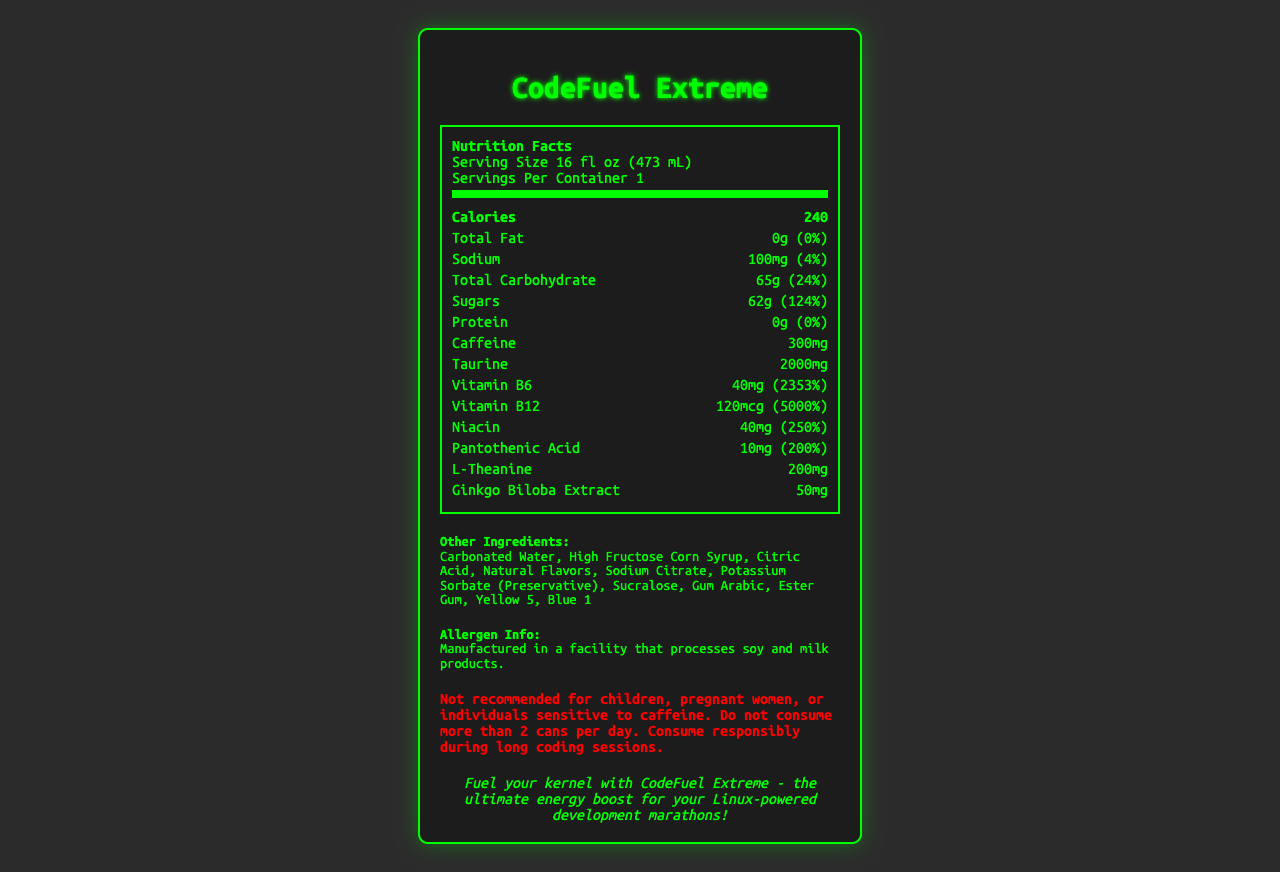what is the serving size of CodeFuel Extreme? The serving size is mentioned at the beginning of the nutrition facts section: "Serving Size 16 fl oz (473 mL)."
Answer: 16 fl oz (473 mL) how many calories are in a serving of CodeFuel Extreme? The calorie count is listed in bold right below the nutrition header as "Calories 240."
Answer: 240 how much sodium does CodeFuel Extreme contain per serving? Under the nutrition facts, sodium is listed as "Sodium 100mg (4%)."
Answer: 100mg what is the percentage daily value of vitamin B6 in CodeFuel Extreme? Vitamin B6's percentage daily value is given as "Vitamin B6 40mg (2353%)."
Answer: 2353% how much sugar is in one serving of CodeFuel Extreme? The sugar content is listed as "Sugars 62g (124%)."
Answer: 62g which of the following vitamins has the highest percentage daily value in CodeFuel Extreme? A. Vitamin B6 B. Vitamin B12 C. Niacin D. Pantothenic Acid Vitamin B12 has the highest percentage daily value at 5000%.
Answer: B how much caffeine is in CodeFuel Extreme? The caffeine amount is listed directly as "Caffeine 300mg."
Answer: 300mg is CodeFuel Extreme recommended for children or pregnant women? The warning section clearly states, "Not recommended for children, pregnant women, or individuals sensitive to caffeine."
Answer: No does CodeFuel Extreme contain any fat? The total fat content is listed as "Total Fat 0g (0%)."
Answer: No summarize the main nutritional components of CodeFuel Extreme. The summary includes the key nutritional components, focusing on high caffeine and vitamin contents, and other essential values from the nutritional facts provided.
Answer: CodeFuel Extreme contains 240 calories per 16 fl oz serving, with high levels of caffeine (300mg), taurine (2000mg), and various vitamins, including vitamin B6 (2353%), vitamin B12 (5000%), niacin (250%), and pantothenic acid (200%). It also contains 62g of sugars (124%) and 100mg of sodium (4%). There is no fat or protein content. what is the No.1 ingredient listed in CodeFuel Extreme? The first ingredient in the "Other Ingredients" list is "Carbonated Water."
Answer: Carbonated Water how much l-theanine is in CodeFuel Extreme? The l-theanine content is listed as "L-Theanine 200mg."
Answer: 200mg what colors are used in CodeFuel Extreme? A. Red B. Yellow and Blue C. Green and Violet The color additives listed are "Yellow 5" and "Blue 1."
Answer: B which vitamin in CodeFuel Extreme has a 250% daily value? The niacin content in the nutrition facts is listed as "Niacin 40mg (250%)."
Answer: Niacin is the daily value for caffeine established in the nutrition facts? The caffeine section mentions "Not established" under daily value.
Answer: No does CodeFuel Extreme contain any allergens? The document states that it is "Manufactured in a facility that processes soy and milk products," but does not explicitly mention if the drink contains any allergens.
Answer: Cannot be determined 